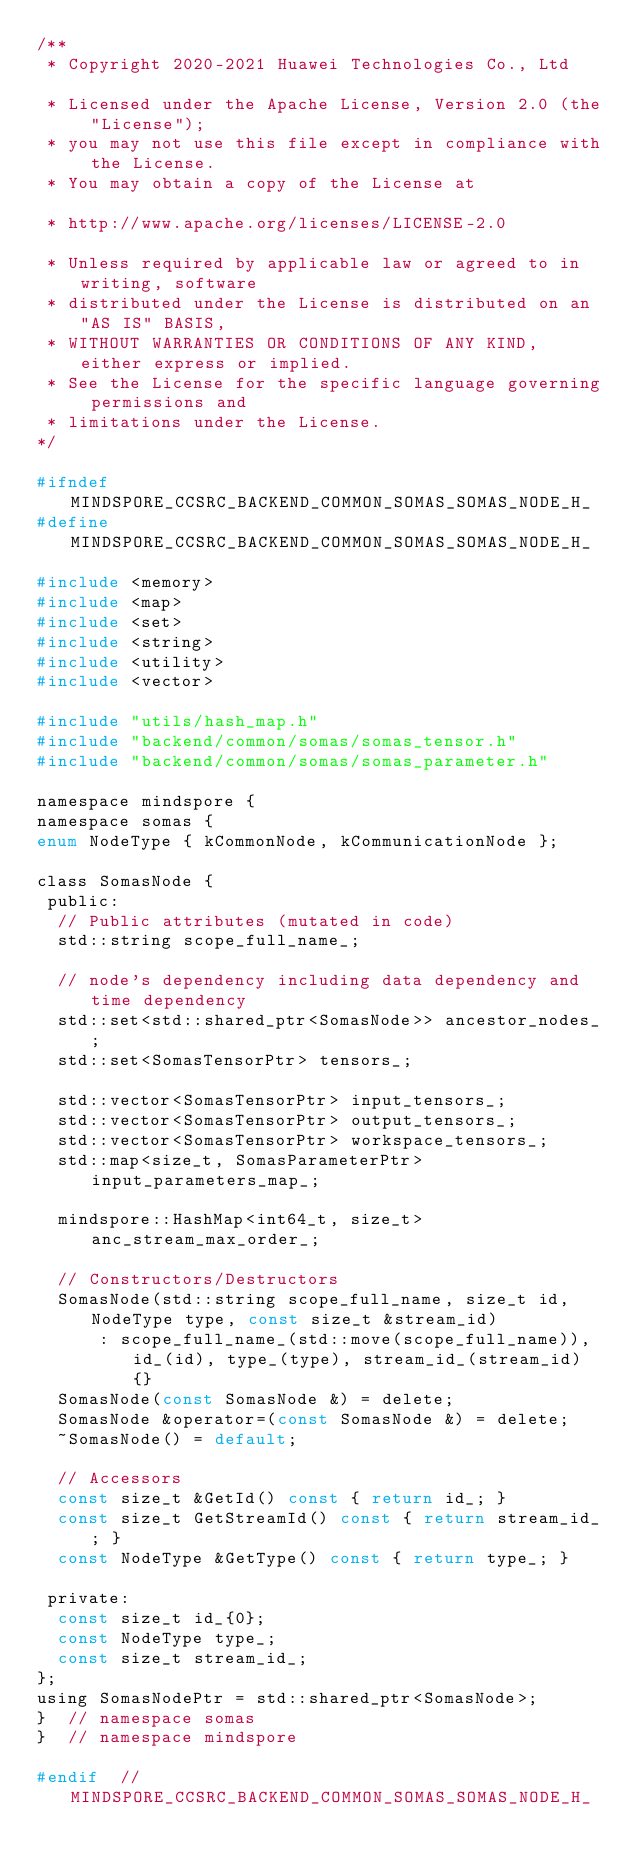<code> <loc_0><loc_0><loc_500><loc_500><_C_>/**
 * Copyright 2020-2021 Huawei Technologies Co., Ltd

 * Licensed under the Apache License, Version 2.0 (the "License");
 * you may not use this file except in compliance with the License.
 * You may obtain a copy of the License at

 * http://www.apache.org/licenses/LICENSE-2.0

 * Unless required by applicable law or agreed to in writing, software
 * distributed under the License is distributed on an "AS IS" BASIS,
 * WITHOUT WARRANTIES OR CONDITIONS OF ANY KIND, either express or implied.
 * See the License for the specific language governing permissions and
 * limitations under the License.
*/

#ifndef MINDSPORE_CCSRC_BACKEND_COMMON_SOMAS_SOMAS_NODE_H_
#define MINDSPORE_CCSRC_BACKEND_COMMON_SOMAS_SOMAS_NODE_H_

#include <memory>
#include <map>
#include <set>
#include <string>
#include <utility>
#include <vector>

#include "utils/hash_map.h"
#include "backend/common/somas/somas_tensor.h"
#include "backend/common/somas/somas_parameter.h"

namespace mindspore {
namespace somas {
enum NodeType { kCommonNode, kCommunicationNode };

class SomasNode {
 public:
  // Public attributes (mutated in code)
  std::string scope_full_name_;

  // node's dependency including data dependency and time dependency
  std::set<std::shared_ptr<SomasNode>> ancestor_nodes_;
  std::set<SomasTensorPtr> tensors_;

  std::vector<SomasTensorPtr> input_tensors_;
  std::vector<SomasTensorPtr> output_tensors_;
  std::vector<SomasTensorPtr> workspace_tensors_;
  std::map<size_t, SomasParameterPtr> input_parameters_map_;

  mindspore::HashMap<int64_t, size_t> anc_stream_max_order_;

  // Constructors/Destructors
  SomasNode(std::string scope_full_name, size_t id, NodeType type, const size_t &stream_id)
      : scope_full_name_(std::move(scope_full_name)), id_(id), type_(type), stream_id_(stream_id) {}
  SomasNode(const SomasNode &) = delete;
  SomasNode &operator=(const SomasNode &) = delete;
  ~SomasNode() = default;

  // Accessors
  const size_t &GetId() const { return id_; }
  const size_t GetStreamId() const { return stream_id_; }
  const NodeType &GetType() const { return type_; }

 private:
  const size_t id_{0};
  const NodeType type_;
  const size_t stream_id_;
};
using SomasNodePtr = std::shared_ptr<SomasNode>;
}  // namespace somas
}  // namespace mindspore

#endif  // MINDSPORE_CCSRC_BACKEND_COMMON_SOMAS_SOMAS_NODE_H_
</code> 